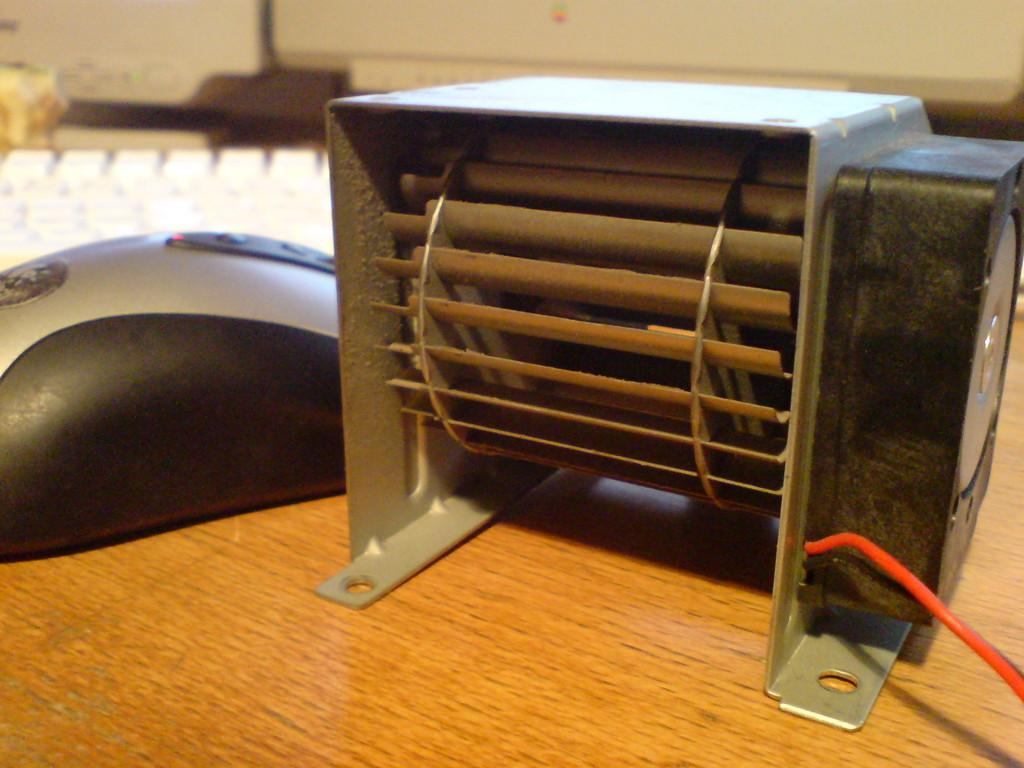What type of electronic device is on the right side of the image? There is an electronic machine on the right side of the image. What is located on the left side of the image? There is a mouse on the left side of the image. What color is the keyboard in the image? The keyboard in the image is white-colored. What type of gold ornament is hanging from the mouse in the image? There is no gold ornament present in the image; it features an electronic machine, a mouse, and a white-colored keyboard. What suggestion does the electronic machine provide in the image? The electronic machine does not provide any suggestions in the image; it is simply an object in the scene. 